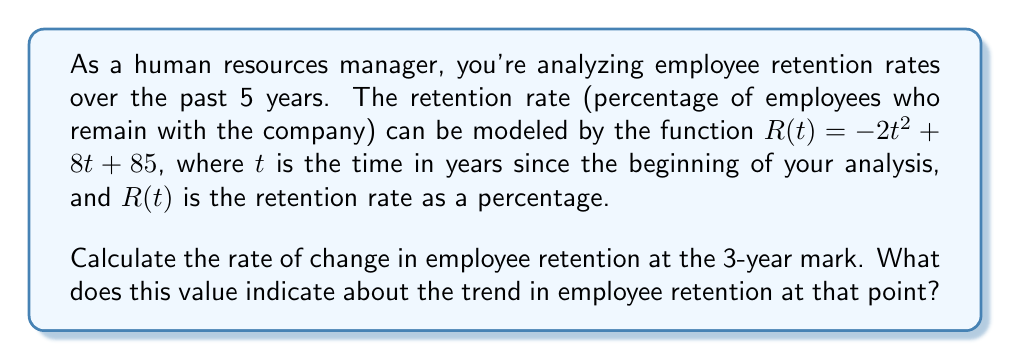Give your solution to this math problem. To solve this problem, we need to find the derivative of the given function and evaluate it at $t = 3$. This will give us the instantaneous rate of change at the 3-year mark.

1. Given function: $R(t) = -2t^2 + 8t + 85$

2. To find the rate of change, we need to calculate the derivative $R'(t)$:
   $$R'(t) = \frac{d}{dt}(-2t^2 + 8t + 85)$$
   $$R'(t) = -4t + 8$$

3. Now, we evaluate $R'(t)$ at $t = 3$:
   $$R'(3) = -4(3) + 8$$
   $$R'(3) = -12 + 8 = -4$$

4. Interpretation:
   The rate of change at $t = 3$ is -4 percentage points per year. The negative value indicates that the retention rate is decreasing at this point in time.

This means that at the 3-year mark, the employee retention rate is dropping by 4 percentage points annually. As an HR manager, this information suggests that you may need to implement new strategies to improve employee retention, as the current trend shows a decline in the retention rate.
Answer: The rate of change in employee retention at the 3-year mark is -4 percentage points per year, indicating a decreasing trend in retention at that point. 